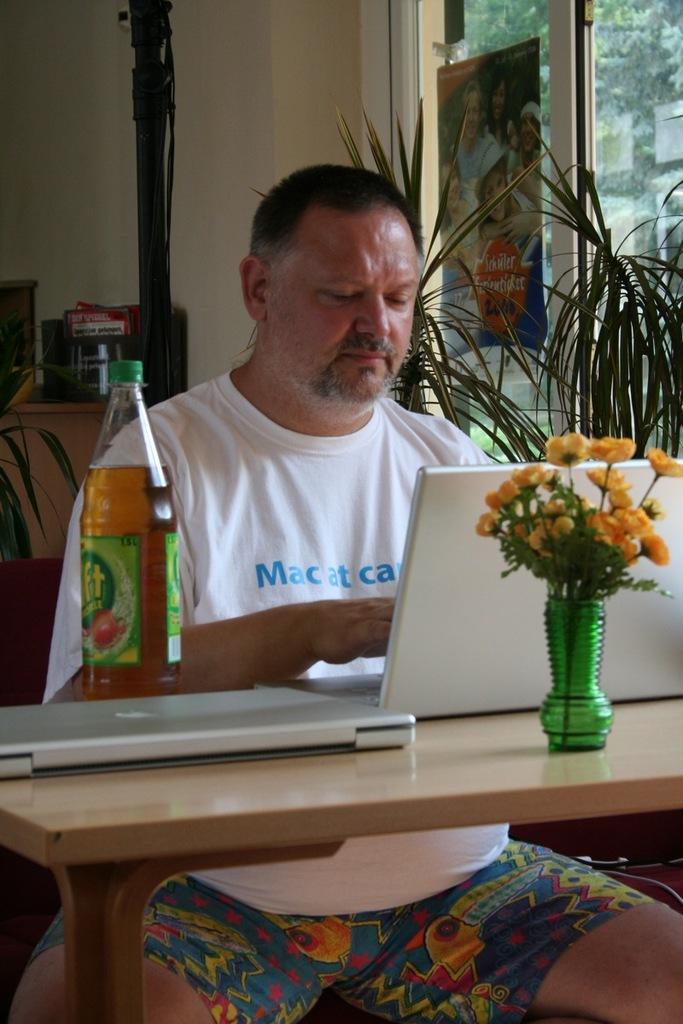Please provide a concise description of this image. This image is clicked inside a room. There are plants on the right side. There is a table in the middle. On that there are bottle, laptop. There is a person in that table. 